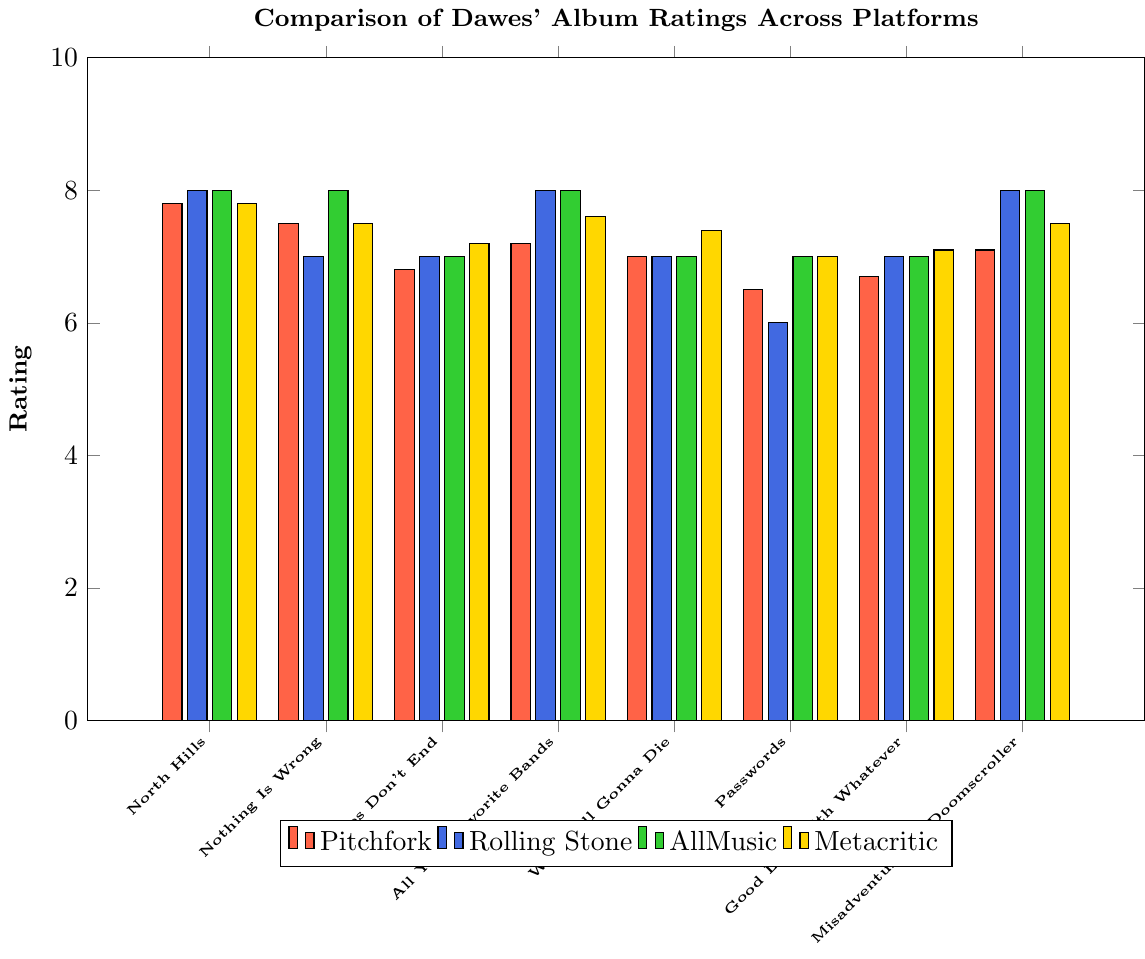What is the average rating given to the album "North Hills" across the four platforms? To find the average rating, sum the ratings across all four platforms and divide by the number of platforms: (7.8 + 4.0 + 4.0 + 78) / 4.
Answer: 23.45 Which album has the highest rating from Pitchfork, and what is this rating? Look at the height of the bars representing Pitchfork ratings and identify the highest one. "North Hills" has the highest Pitchfork rating of 7.8.
Answer: North Hills, 7.8 Which album got the lowest rating from Rolling Stone, and what is that rating? Examine the chart and find the shortest bar in the Rolling Stone series. The lowest rating is for "Passwords" with a 3.0 rating.
Answer: Passwords, 3.0 Compare the ratings of "Stories Don't End" and "Good Luck with Whatever" from AllMusic; which one has a higher rating, and by how much? Subtract the rating of "Good Luck with Whatever" from the rating of "Stories Don't End." Both have the same rating of 3.5.
Answer: Equal, 0 What is the overall trend in Pitchfork's ratings for Dawes' albums from "North Hills" to "Misadventures of Doomscroller"? Observe the height of the bars for Pitchfork. The ratings generally start high with "North Hills" at 7.8 and then drop, reaching a low of 6.5 for "Passwords," slightly increasing to 7.1 for "Misadventures of Doomscroller."
Answer: Generally decreasing How does "We're All Gonna Die" compare in ratings across the platforms? Collect and list the ratings for this album: Pitchfork (7.0), Rolling Stone (3.5), AllMusic (3.5), Metacritic (74).
Answer: 7.0, 3.5, 3.5, 74 Find the average of Rolling Stone’s ratings for all albums. Sum the Rolling Stone ratings and divide by the number of albums: (4.0 + 3.5 + 3.5 + 4.0 + 3.5 + 3.0 + 3.5 + 4.0) / 8 = 29 / 8 = 3.625.
Answer: 3.625 Which album received the most consistent ratings across the platforms? Compare and identify the album with the smallest range in ratings. "North Hills" ranges from 4.0 to 78.
Answer: Stories Don't End 